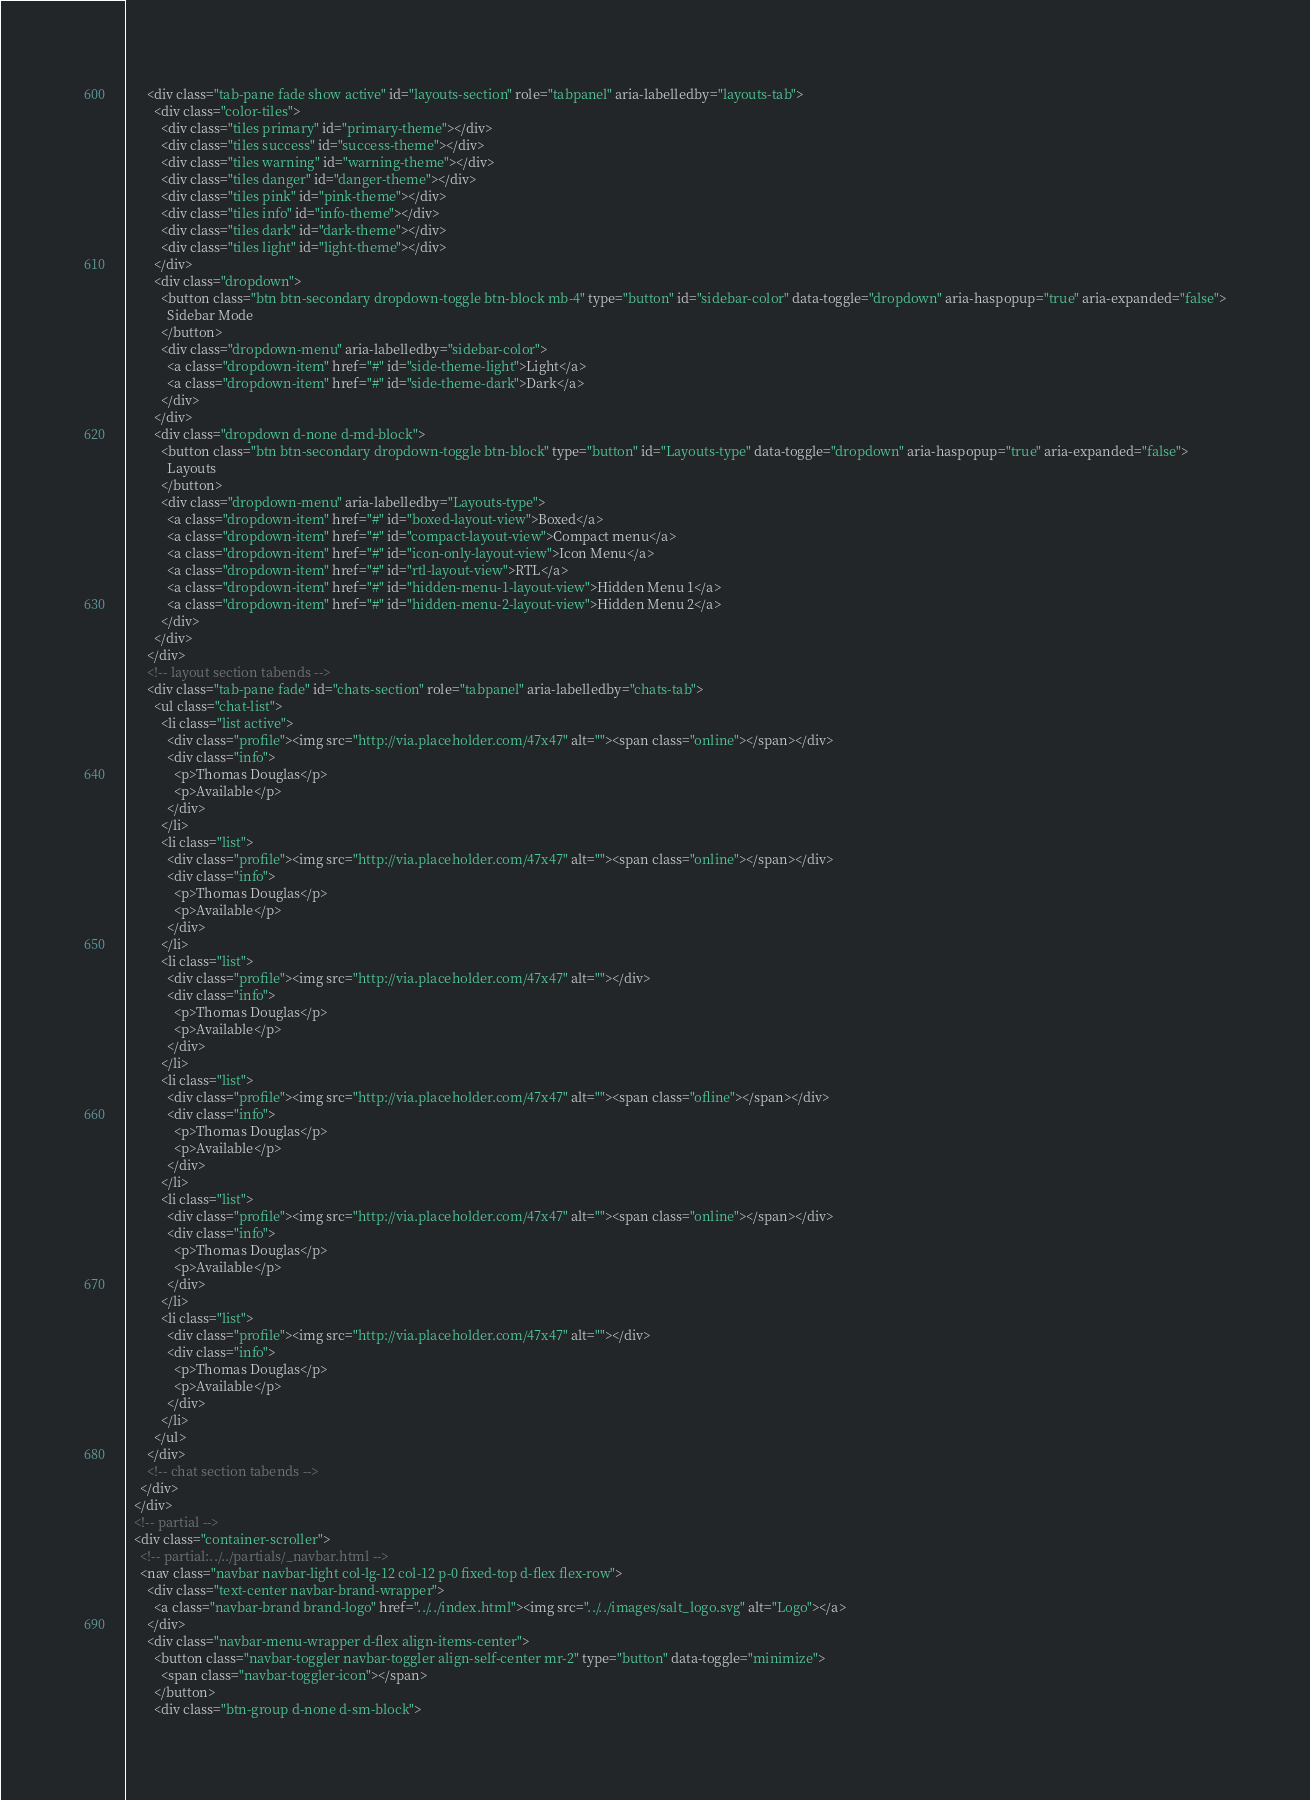<code> <loc_0><loc_0><loc_500><loc_500><_HTML_>      <div class="tab-pane fade show active" id="layouts-section" role="tabpanel" aria-labelledby="layouts-tab">
        <div class="color-tiles">
          <div class="tiles primary" id="primary-theme"></div>
          <div class="tiles success" id="success-theme"></div>
          <div class="tiles warning" id="warning-theme"></div>
          <div class="tiles danger" id="danger-theme"></div>
          <div class="tiles pink" id="pink-theme"></div>
          <div class="tiles info" id="info-theme"></div>
          <div class="tiles dark" id="dark-theme"></div>
          <div class="tiles light" id="light-theme"></div>
        </div>
        <div class="dropdown">
          <button class="btn btn-secondary dropdown-toggle btn-block mb-4" type="button" id="sidebar-color" data-toggle="dropdown" aria-haspopup="true" aria-expanded="false">
            Sidebar Mode
          </button>
          <div class="dropdown-menu" aria-labelledby="sidebar-color">
            <a class="dropdown-item" href="#" id="side-theme-light">Light</a>
            <a class="dropdown-item" href="#" id="side-theme-dark">Dark</a>
          </div>
        </div>
        <div class="dropdown d-none d-md-block">
          <button class="btn btn-secondary dropdown-toggle btn-block" type="button" id="Layouts-type" data-toggle="dropdown" aria-haspopup="true" aria-expanded="false">
            Layouts
          </button>
          <div class="dropdown-menu" aria-labelledby="Layouts-type">
            <a class="dropdown-item" href="#" id="boxed-layout-view">Boxed</a>
            <a class="dropdown-item" href="#" id="compact-layout-view">Compact menu</a>
            <a class="dropdown-item" href="#" id="icon-only-layout-view">Icon Menu</a>
            <a class="dropdown-item" href="#" id="rtl-layout-view">RTL</a>
            <a class="dropdown-item" href="#" id="hidden-menu-1-layout-view">Hidden Menu 1</a>
            <a class="dropdown-item" href="#" id="hidden-menu-2-layout-view">Hidden Menu 2</a>
          </div>
        </div>
      </div>
      <!-- layout section tabends -->
      <div class="tab-pane fade" id="chats-section" role="tabpanel" aria-labelledby="chats-tab">
        <ul class="chat-list">
          <li class="list active">
            <div class="profile"><img src="http://via.placeholder.com/47x47" alt=""><span class="online"></span></div>
            <div class="info">
              <p>Thomas Douglas</p>
              <p>Available</p>
            </div>
          </li>
          <li class="list">
            <div class="profile"><img src="http://via.placeholder.com/47x47" alt=""><span class="online"></span></div>
            <div class="info">
              <p>Thomas Douglas</p>
              <p>Available</p>
            </div>
          </li>
          <li class="list">
            <div class="profile"><img src="http://via.placeholder.com/47x47" alt=""></div>
            <div class="info">
              <p>Thomas Douglas</p>
              <p>Available</p>
            </div>
          </li>
          <li class="list">
            <div class="profile"><img src="http://via.placeholder.com/47x47" alt=""><span class="ofline"></span></div>
            <div class="info">
              <p>Thomas Douglas</p>
              <p>Available</p>
            </div>
          </li>
          <li class="list">
            <div class="profile"><img src="http://via.placeholder.com/47x47" alt=""><span class="online"></span></div>
            <div class="info">
              <p>Thomas Douglas</p>
              <p>Available</p>
            </div>
          </li>
          <li class="list">
            <div class="profile"><img src="http://via.placeholder.com/47x47" alt=""></div>
            <div class="info">
              <p>Thomas Douglas</p>
              <p>Available</p>
            </div>
          </li>
        </ul>
      </div>
      <!-- chat section tabends -->
    </div>
  </div>
  <!-- partial -->
  <div class="container-scroller">
    <!-- partial:../../partials/_navbar.html -->
    <nav class="navbar navbar-light col-lg-12 col-12 p-0 fixed-top d-flex flex-row">
      <div class="text-center navbar-brand-wrapper">
        <a class="navbar-brand brand-logo" href="../../index.html"><img src="../../images/salt_logo.svg" alt="Logo"></a>
      </div>
      <div class="navbar-menu-wrapper d-flex align-items-center">
        <button class="navbar-toggler navbar-toggler align-self-center mr-2" type="button" data-toggle="minimize">
          <span class="navbar-toggler-icon"></span>
        </button>
        <div class="btn-group d-none d-sm-block"></code> 